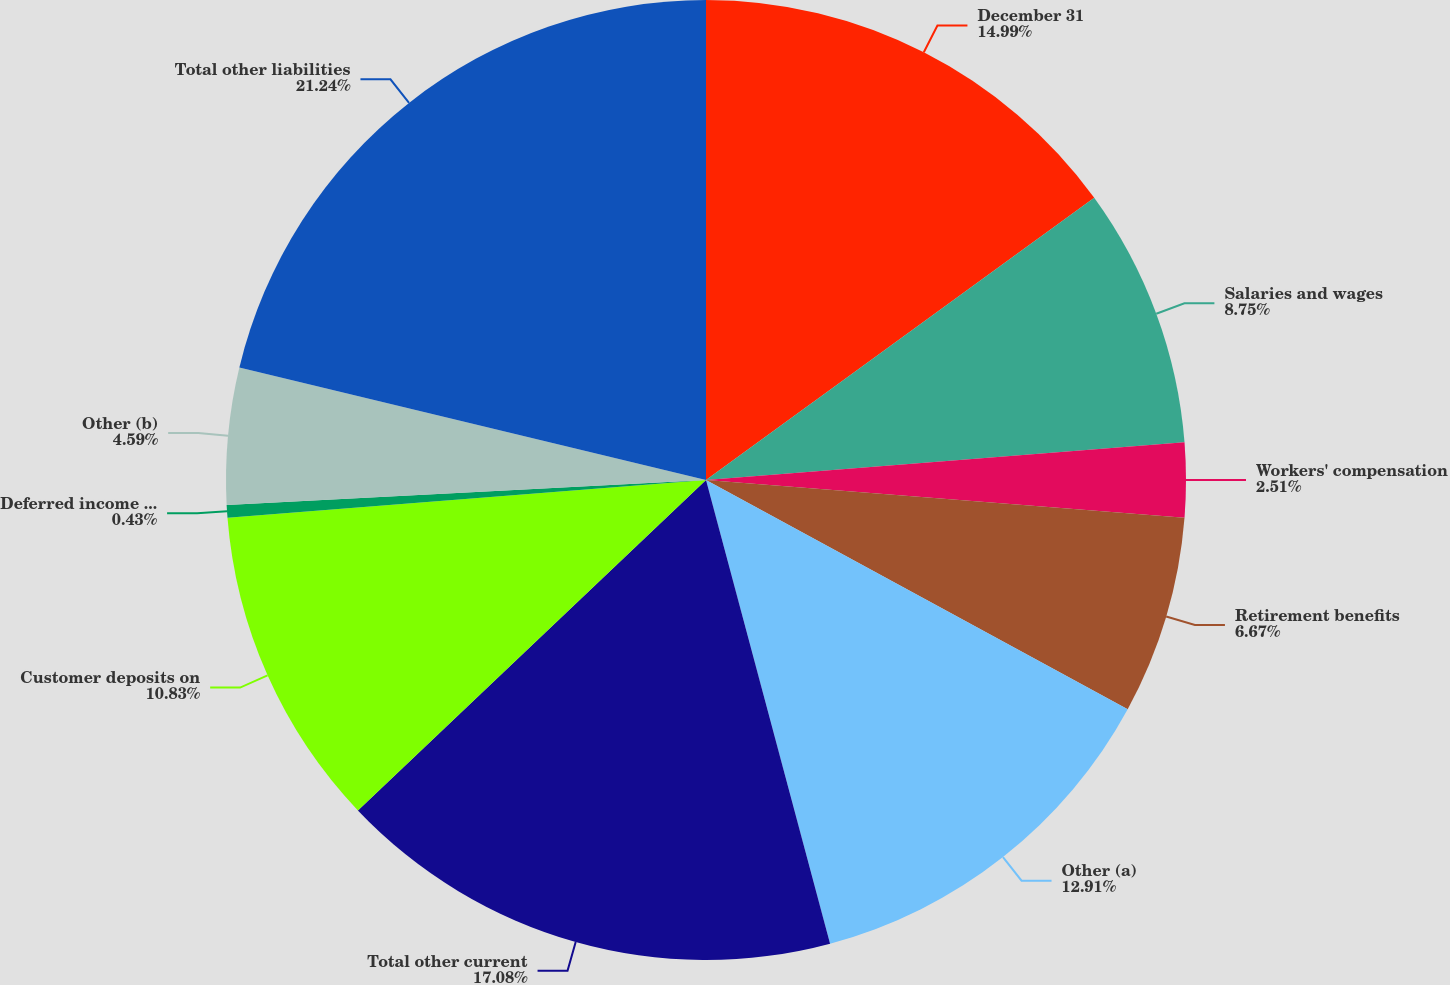<chart> <loc_0><loc_0><loc_500><loc_500><pie_chart><fcel>December 31<fcel>Salaries and wages<fcel>Workers' compensation<fcel>Retirement benefits<fcel>Other (a)<fcel>Total other current<fcel>Customer deposits on<fcel>Deferred income taxes<fcel>Other (b)<fcel>Total other liabilities<nl><fcel>14.99%<fcel>8.75%<fcel>2.51%<fcel>6.67%<fcel>12.91%<fcel>17.07%<fcel>10.83%<fcel>0.43%<fcel>4.59%<fcel>21.23%<nl></chart> 